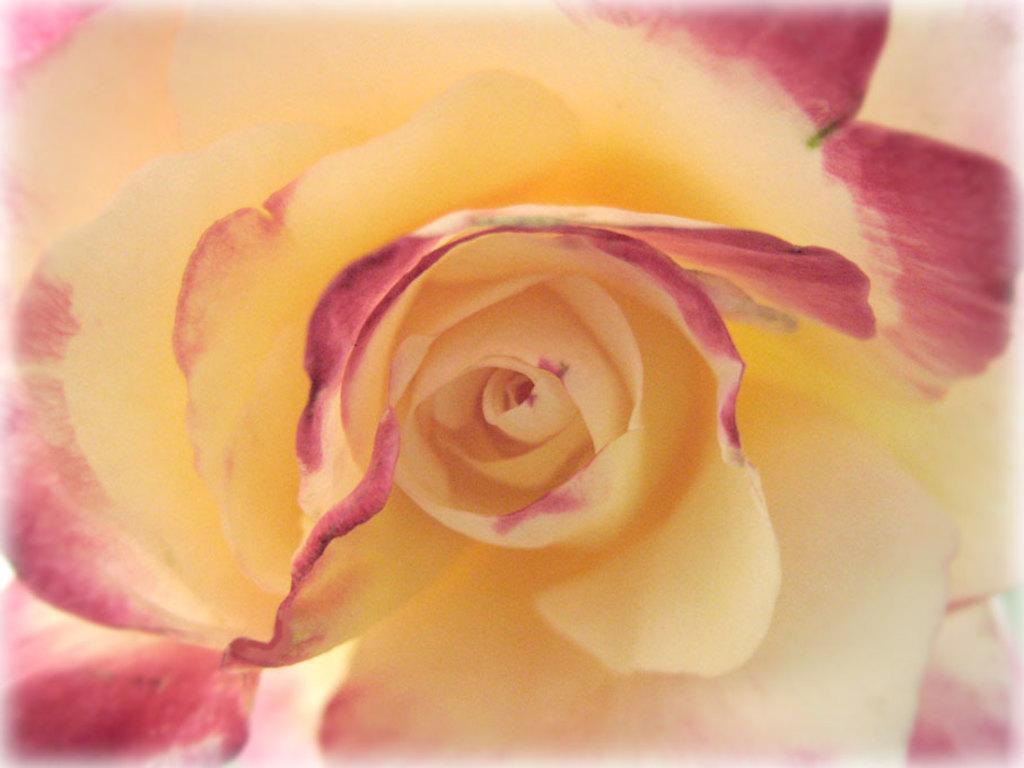What type of flower is present in the image? There is a yellow flower in the image. Can you describe the petals of the flower? The petals of the flower have pink color at the corners. What is the effect of the locket on the flower in the image? There is no locket present in the image, so there is no effect on the flower. 